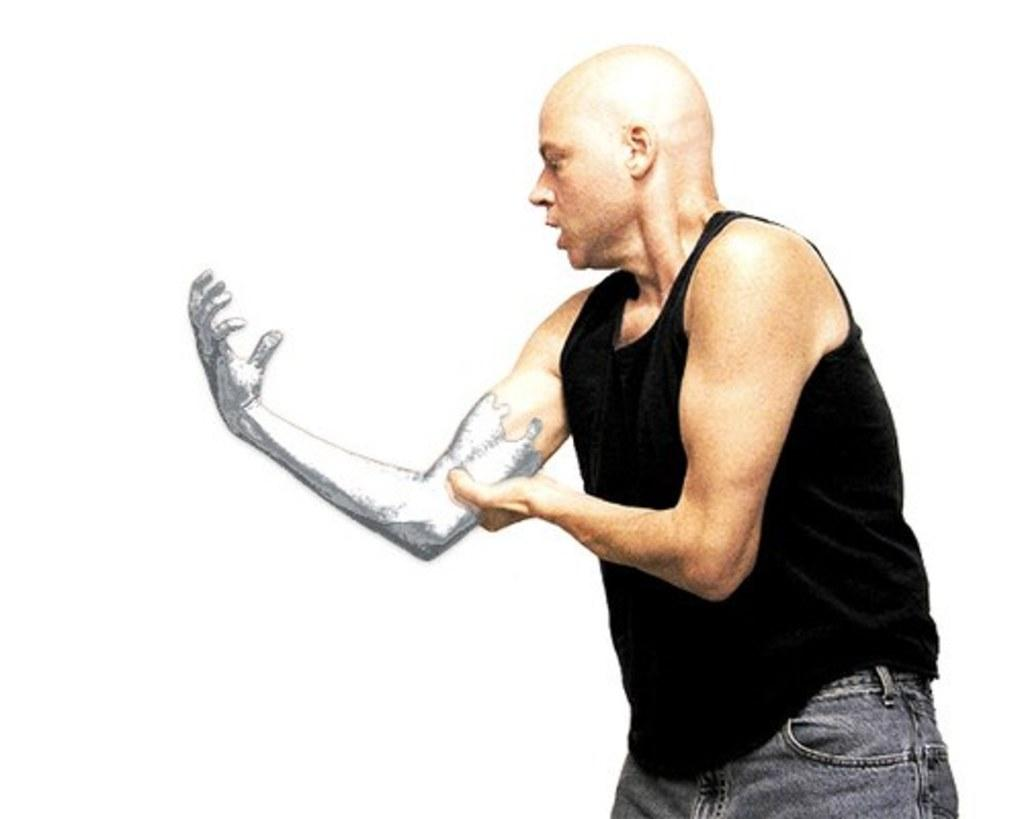What is the main subject of the image? There is a man in the image. What is the man doing in the image? The man is standing in the image. What is the man holding in the image? The man is holding the muscle of his right hand in the image. What type of memory is the man using to recall information in the image? There is no indication in the image that the man is using any type of memory to recall information. 